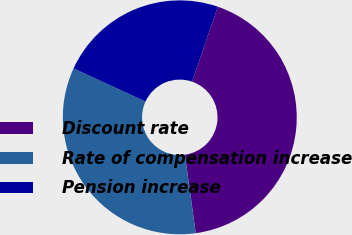Convert chart to OTSL. <chart><loc_0><loc_0><loc_500><loc_500><pie_chart><fcel>Discount rate<fcel>Rate of compensation increase<fcel>Pension increase<nl><fcel>42.55%<fcel>34.04%<fcel>23.4%<nl></chart> 